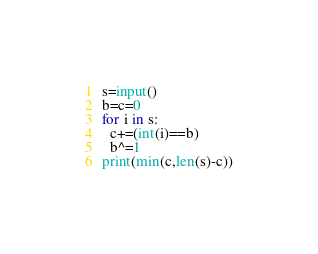<code> <loc_0><loc_0><loc_500><loc_500><_Python_>s=input()
b=c=0
for i in s:
  c+=(int(i)==b)
  b^=1
print(min(c,len(s)-c))</code> 